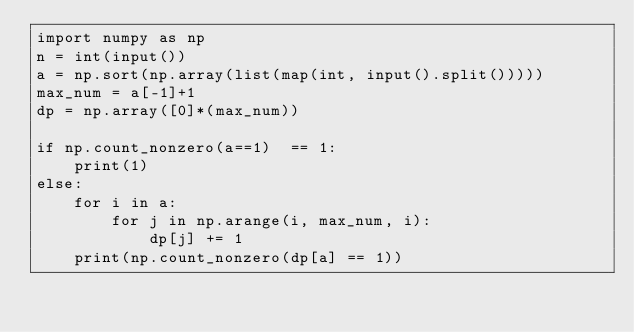<code> <loc_0><loc_0><loc_500><loc_500><_Python_>import numpy as np
n = int(input())
a = np.sort(np.array(list(map(int, input().split()))))
max_num = a[-1]+1
dp = np.array([0]*(max_num))

if np.count_nonzero(a==1)  == 1:
    print(1)
else:
    for i in a:
        for j in np.arange(i, max_num, i):
            dp[j] += 1
    print(np.count_nonzero(dp[a] == 1))</code> 